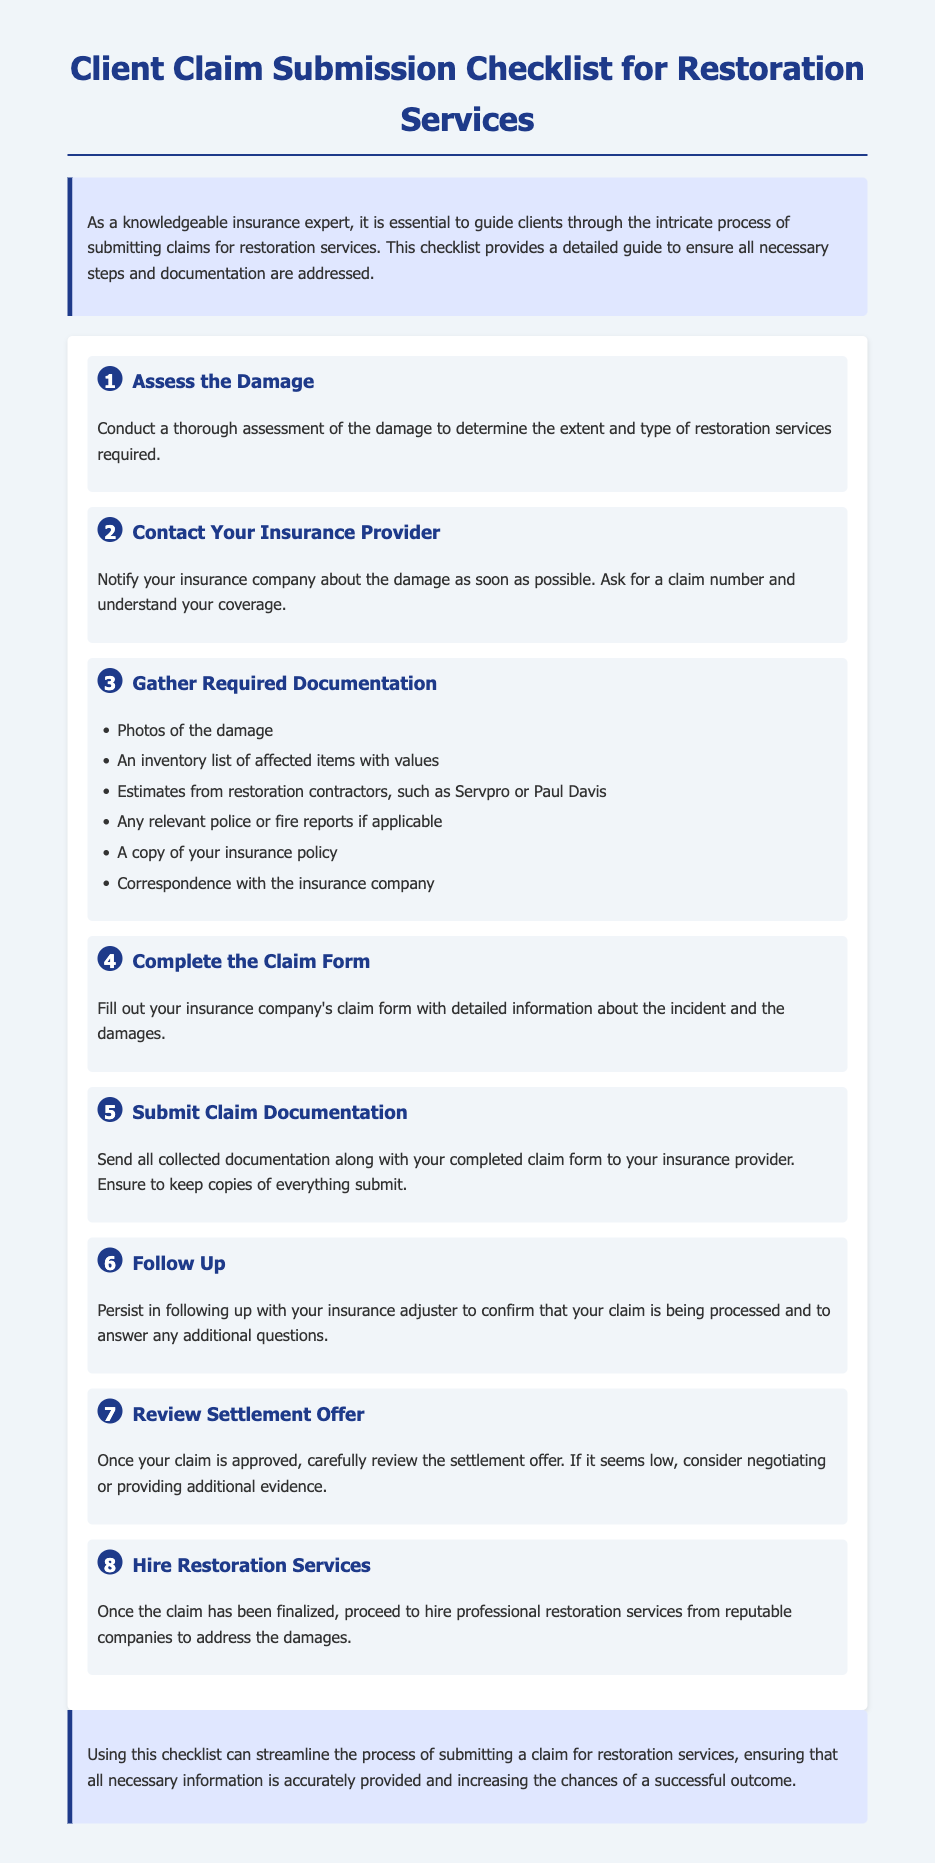what is the first step in the claim submission process? The first step is to assess the damage to determine the extent and type of restoration services required.
Answer: Assess the Damage what should you notify the insurance company about? You should notify the insurance company about the damage as soon as possible.
Answer: Damage how many types of required documentation are listed? The document outlines six types of required documentation needed for claim submission.
Answer: Six what needs to be filled out after gathering documentation? After gathering documentation, you need to complete the insurance company's claim form.
Answer: Claim form what should you do if the settlement offer seems low? If the settlement offer seems low, you should consider negotiating or providing additional evidence.
Answer: Negotiate what is the ultimate goal of using the checklist? The ultimate goal is to streamline the process of submitting a claim for restoration services.
Answer: Streamline who should you hire after the claim has been finalized? You should hire professional restoration services from reputable companies after the claim has been finalized.
Answer: Professional restoration services how many steps are there in the checklist? The checklist consists of eight steps.
Answer: Eight 